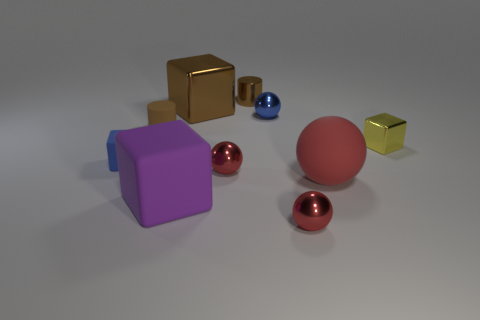What size is the yellow thing that is the same material as the brown cube?
Your response must be concise. Small. How many blue metal things have the same shape as the tiny brown rubber object?
Ensure brevity in your answer.  0. Is there any other thing that is the same size as the brown cube?
Provide a short and direct response. Yes. What size is the purple rubber thing that is in front of the sphere behind the yellow block?
Keep it short and to the point. Large. There is a purple object that is the same size as the matte sphere; what is its material?
Ensure brevity in your answer.  Rubber. Is there a big block that has the same material as the tiny yellow cube?
Make the answer very short. Yes. There is a matte cube to the right of the cylinder in front of the cube that is behind the tiny yellow thing; what is its color?
Your answer should be very brief. Purple. Is the color of the small metallic sphere behind the tiny metallic cube the same as the rubber object behind the small metal cube?
Make the answer very short. No. Is there any other thing of the same color as the rubber ball?
Provide a short and direct response. Yes. Are there fewer big red balls in front of the purple object than tiny green metallic things?
Your answer should be compact. No. 